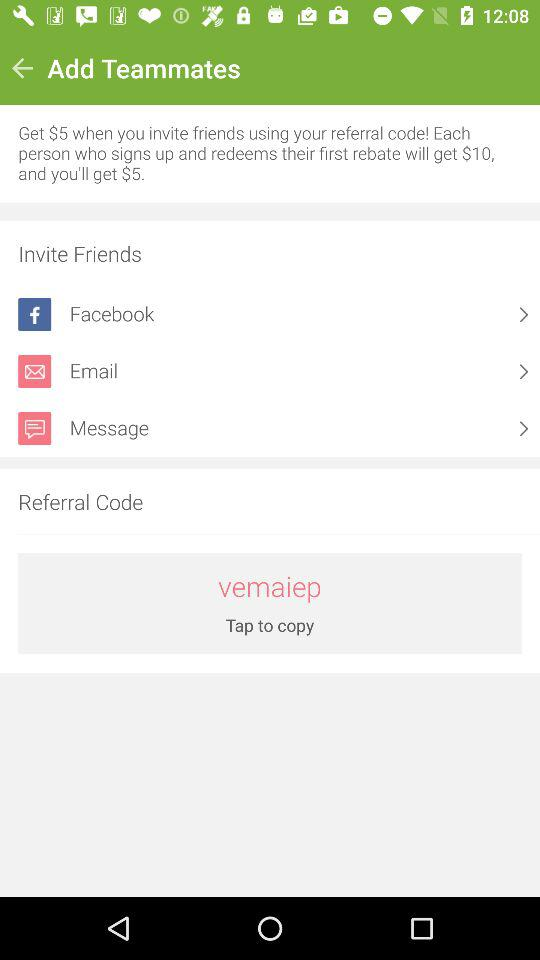What is the amount we get after a referral? The amount is $5. 